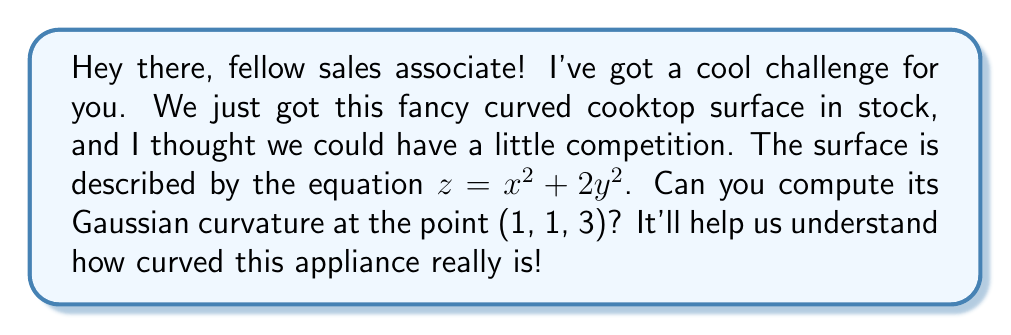Can you answer this question? Alright, let's break this down step-by-step:

1) The Gaussian curvature K is given by the formula:

   $$K = \frac{LN - M^2}{EG - F^2}$$

   where L, M, N are coefficients of the second fundamental form, and E, F, G are coefficients of the first fundamental form.

2) For a surface given by $z = f(x,y)$, we have:

   $$E = 1 + f_x^2, \quad F = f_x f_y, \quad G = 1 + f_y^2$$
   $$L = \frac{f_{xx}}{\sqrt{1 + f_x^2 + f_y^2}}, \quad M = \frac{f_{xy}}{\sqrt{1 + f_x^2 + f_y^2}}, \quad N = \frac{f_{yy}}{\sqrt{1 + f_x^2 + f_y^2}}$$

3) For our surface $z = x^2 + 2y^2$, we have:

   $f_x = 2x, \quad f_y = 4y$
   $f_{xx} = 2, \quad f_{xy} = 0, \quad f_{yy} = 4$

4) At the point (1, 1, 3):

   $f_x = 2, \quad f_y = 4$

5) Now let's calculate E, F, G:

   $$E = 1 + (2)^2 = 5$$
   $$F = 2 \cdot 4 = 8$$
   $$G = 1 + (4)^2 = 17$$

6) And L, M, N:

   $$L = \frac{2}{\sqrt{1 + 2^2 + 4^2}} = \frac{2}{\sqrt{21}}$$
   $$M = \frac{0}{\sqrt{21}} = 0$$
   $$N = \frac{4}{\sqrt{21}}$$

7) Now we can compute K:

   $$K = \frac{LN - M^2}{EG - F^2} = \frac{(\frac{2}{\sqrt{21}})(\frac{4}{\sqrt{21}}) - 0^2}{5(17) - 8^2}$$

8) Simplifying:

   $$K = \frac{\frac{8}{21}}{85 - 64} = \frac{\frac{8}{21}}{21} = \frac{8}{441}$$
Answer: $\frac{8}{441}$ 